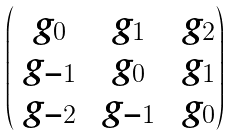<formula> <loc_0><loc_0><loc_500><loc_500>\begin{pmatrix} \ g _ { 0 } & \ g _ { 1 } & \ g _ { 2 } \\ \ g _ { - 1 } & \ g _ { 0 } & \ g _ { 1 } \\ \ g _ { - 2 } & \ g _ { - 1 } & \ g _ { 0 } \\ \end{pmatrix}</formula> 